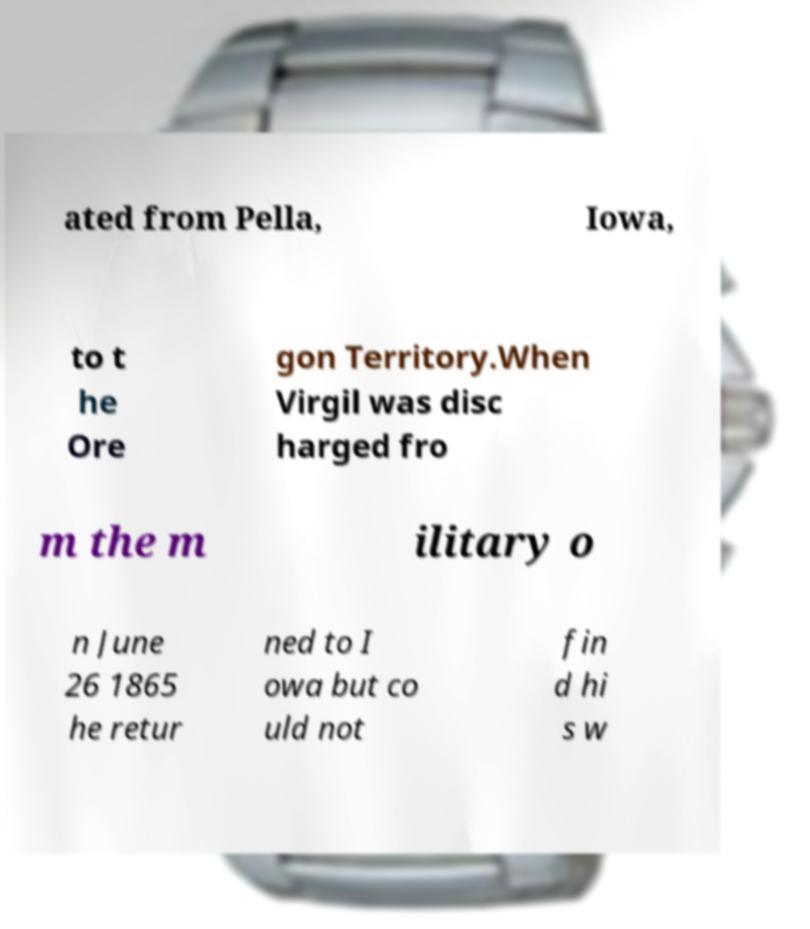Can you accurately transcribe the text from the provided image for me? ated from Pella, Iowa, to t he Ore gon Territory.When Virgil was disc harged fro m the m ilitary o n June 26 1865 he retur ned to I owa but co uld not fin d hi s w 